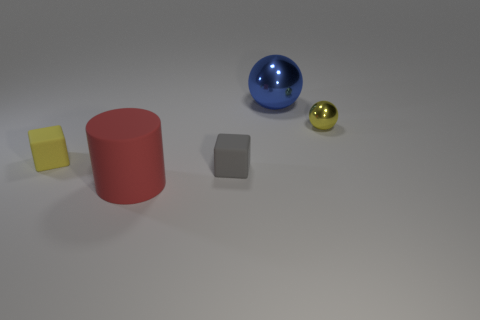Add 4 red metal cubes. How many objects exist? 9 Subtract all cubes. How many objects are left? 3 Add 5 big red cylinders. How many big red cylinders exist? 6 Subtract 0 purple spheres. How many objects are left? 5 Subtract all small gray matte cubes. Subtract all tiny rubber objects. How many objects are left? 2 Add 4 small metallic spheres. How many small metallic spheres are left? 5 